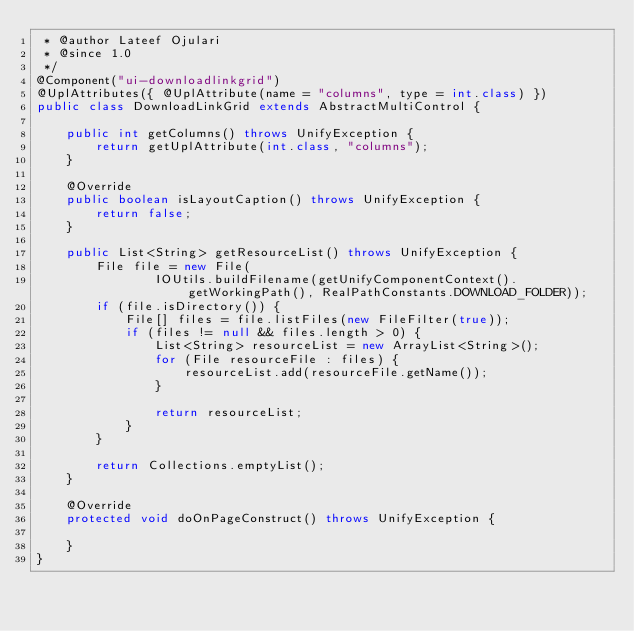<code> <loc_0><loc_0><loc_500><loc_500><_Java_> * @author Lateef Ojulari
 * @since 1.0
 */
@Component("ui-downloadlinkgrid")
@UplAttributes({ @UplAttribute(name = "columns", type = int.class) })
public class DownloadLinkGrid extends AbstractMultiControl {

    public int getColumns() throws UnifyException {
        return getUplAttribute(int.class, "columns");
    }

    @Override
    public boolean isLayoutCaption() throws UnifyException {
        return false;
    }

    public List<String> getResourceList() throws UnifyException {
        File file = new File(
                IOUtils.buildFilename(getUnifyComponentContext().getWorkingPath(), RealPathConstants.DOWNLOAD_FOLDER));
        if (file.isDirectory()) {
            File[] files = file.listFiles(new FileFilter(true));
            if (files != null && files.length > 0) {
                List<String> resourceList = new ArrayList<String>();
                for (File resourceFile : files) {
                    resourceList.add(resourceFile.getName());
                }

                return resourceList;
            }
        }

        return Collections.emptyList();
    }

    @Override
    protected void doOnPageConstruct() throws UnifyException {
        
    }
}
</code> 